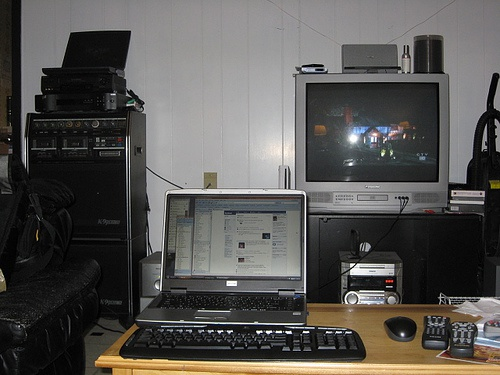Describe the objects in this image and their specific colors. I can see tv in black, gray, and purple tones, laptop in black, gray, darkgray, and lightgray tones, couch in black and gray tones, chair in black and gray tones, and keyboard in black, gray, and darkgreen tones in this image. 